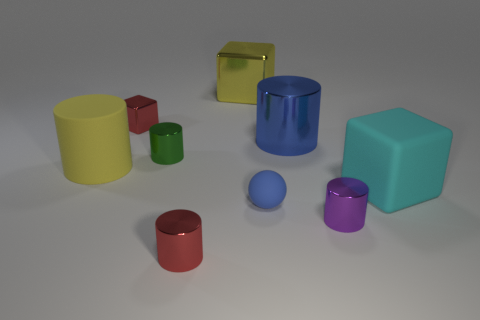Subtract all red cylinders. How many cylinders are left? 4 Subtract all cyan cylinders. Subtract all blue blocks. How many cylinders are left? 5 Subtract all cubes. How many objects are left? 6 Subtract 1 red cubes. How many objects are left? 8 Subtract all cyan rubber objects. Subtract all yellow cylinders. How many objects are left? 7 Add 8 small green shiny things. How many small green shiny things are left? 9 Add 3 metal cylinders. How many metal cylinders exist? 7 